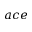Convert formula to latex. <formula><loc_0><loc_0><loc_500><loc_500>a c e</formula> 